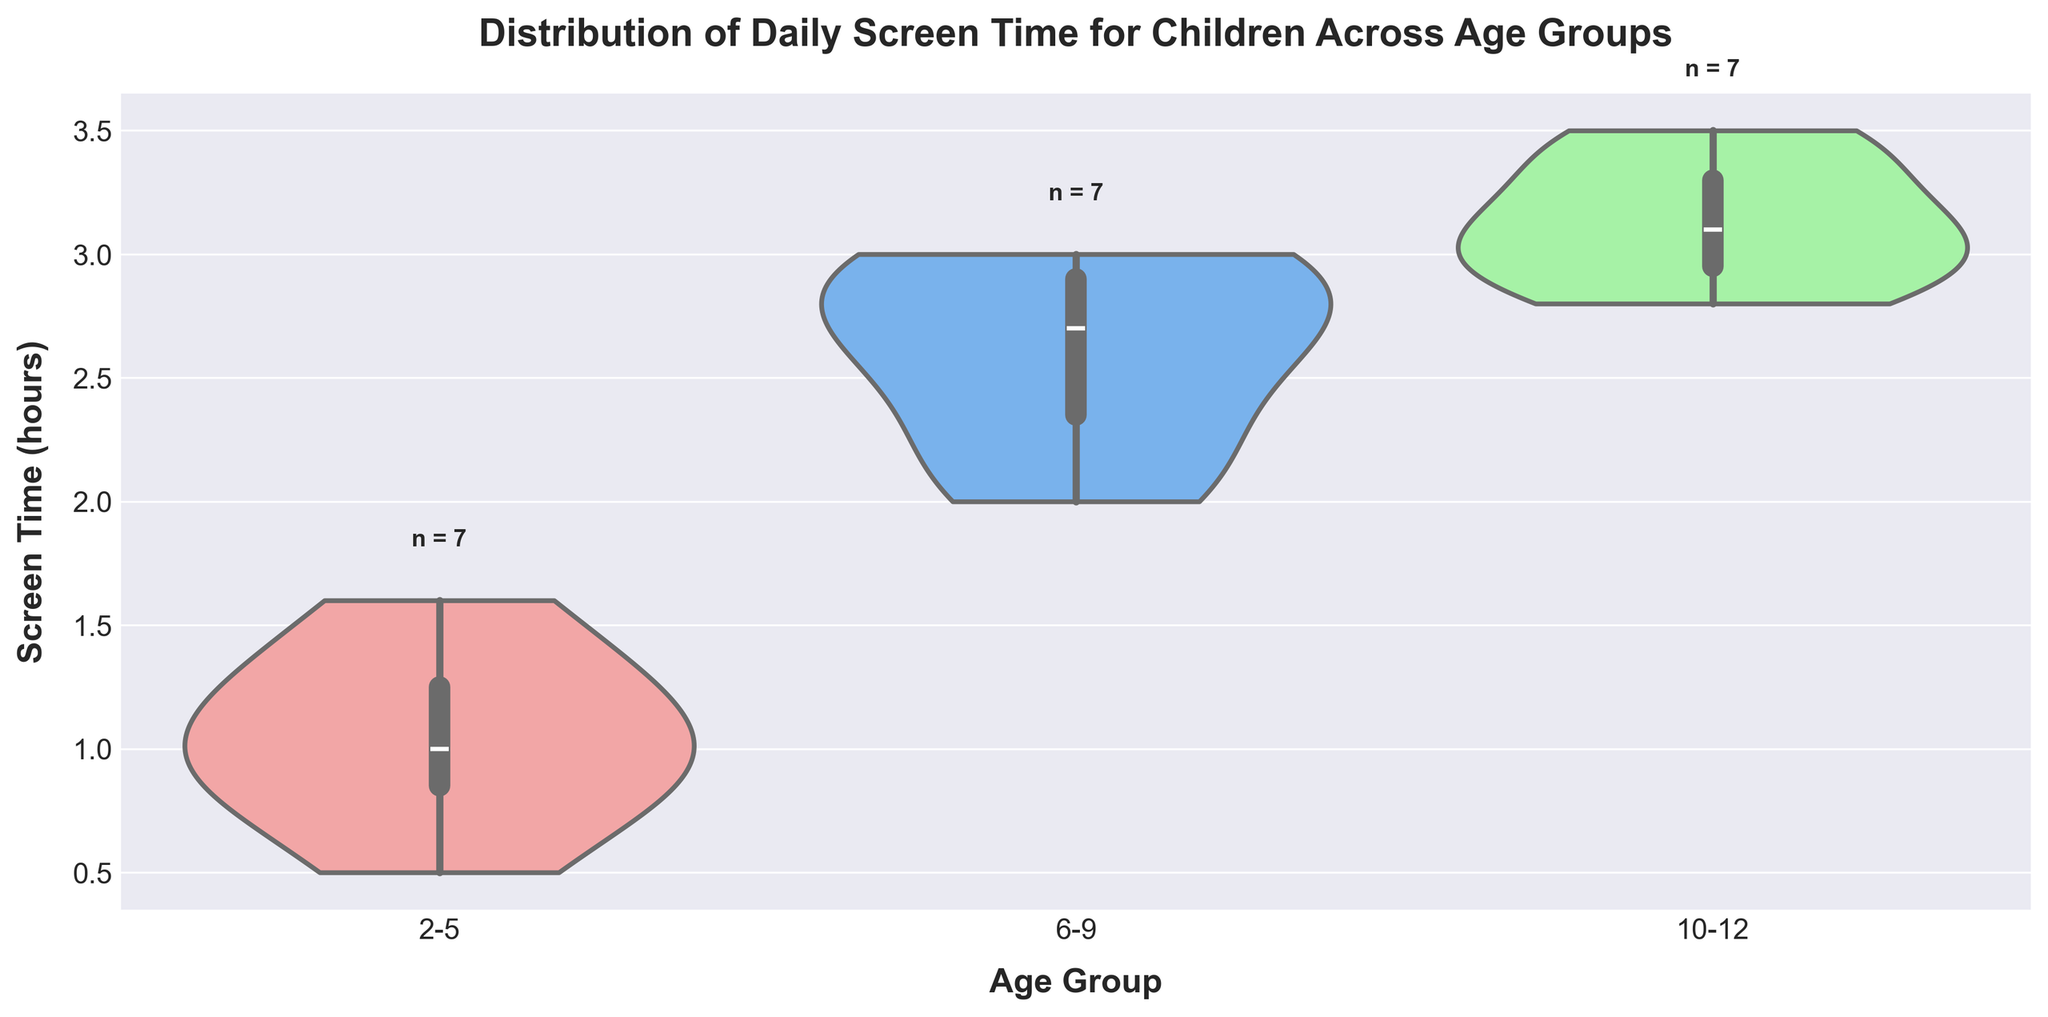What is the title of the plot? The title of the plot is written at the top and describes the main idea of the figure. It helps to quickly understand what the plot is about. The title is "Distribution of Daily Screen Time for Children Across Age Groups".
Answer: Distribution of Daily Screen Time for Children Across Age Groups How many different age groups are represented in this plot? The plot categorizes the data into different age groups along the x-axis. By counting the distinct labels on the x-axis, we can determine the number of age groups. There are three age groups represented: "2-5", "6-9", and "10-12".
Answer: 3 Which age group has the highest median screen time? In a violin plot, the median can be identified by looking at the white dot within the inner box of each violin shape. The age group with the highest median has the white dot positioned highest on the y-axis. The "10-12" age group has the highest median screen time.
Answer: 10-12 What is the range of screen time hours for the "6-9" age group? The range of screen time for an age group can be determined by looking at the extent of the violin shape along the y-axis for that group. For the "6-9" age group, the screen time ranges from approximately 2.0 to 3.0 hours.
Answer: 2.0 to 3.0 hours How many children are in the "2-5" age group? The number of children in each age group is indicated by the text label just above each violin plot. For the "2-5" age group, the text label shows "n = 7".
Answer: 7 Which age group shows the most variability in screen time hours? Variability can be judged by the width and distribution spread of the violin plot. The wider and more spread out the plot, the higher the variability. The "10-12" age group shows the most variability.
Answer: 10-12 Between which two age groups is the difference in median screen time the greatest? To find the difference in median screen time, compare the positions of the white dots within the inner boxes of the violin plots for each age group. The white dot for "10-12" is much higher than the white dot for "2-5", indicating the greatest difference is between these two groups.
Answer: 2-5 and 10-12 What is the screen time of the child with the highest recorded screen time? The highest recorded screen time can be observed at the upper extremity of the violin plot. The maximum value is at the top of the "10-12" age group, which is about 3.5 hours.
Answer: 3.5 hours Which age group has a median screen time lower than 3 hours but higher than 1 hour? The median screen time for each age group is indicated by the white dot within the box inside the violin plot. The "6-9" age group has a median screen time within this range.
Answer: 6-9 